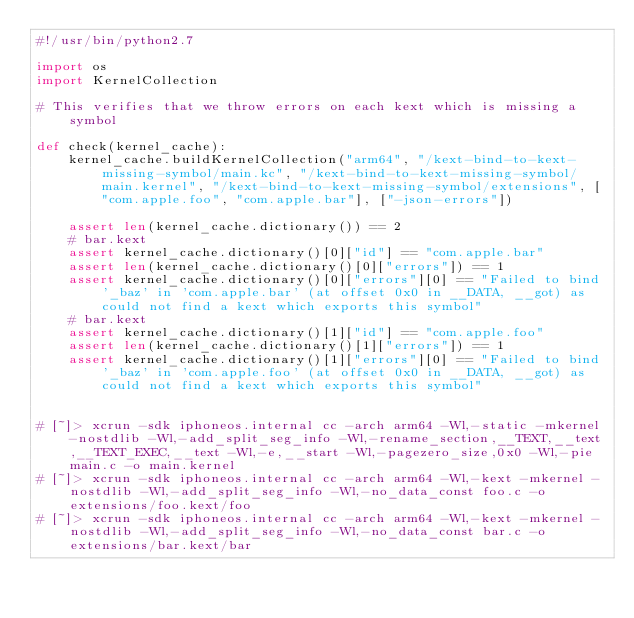Convert code to text. <code><loc_0><loc_0><loc_500><loc_500><_Python_>#!/usr/bin/python2.7

import os
import KernelCollection

# This verifies that we throw errors on each kext which is missing a symbol

def check(kernel_cache):
    kernel_cache.buildKernelCollection("arm64", "/kext-bind-to-kext-missing-symbol/main.kc", "/kext-bind-to-kext-missing-symbol/main.kernel", "/kext-bind-to-kext-missing-symbol/extensions", ["com.apple.foo", "com.apple.bar"], ["-json-errors"])

    assert len(kernel_cache.dictionary()) == 2
    # bar.kext
    assert kernel_cache.dictionary()[0]["id"] == "com.apple.bar"
    assert len(kernel_cache.dictionary()[0]["errors"]) == 1
    assert kernel_cache.dictionary()[0]["errors"][0] == "Failed to bind '_baz' in 'com.apple.bar' (at offset 0x0 in __DATA, __got) as could not find a kext which exports this symbol"
    # bar.kext
    assert kernel_cache.dictionary()[1]["id"] == "com.apple.foo"
    assert len(kernel_cache.dictionary()[1]["errors"]) == 1
    assert kernel_cache.dictionary()[1]["errors"][0] == "Failed to bind '_baz' in 'com.apple.foo' (at offset 0x0 in __DATA, __got) as could not find a kext which exports this symbol"


# [~]> xcrun -sdk iphoneos.internal cc -arch arm64 -Wl,-static -mkernel -nostdlib -Wl,-add_split_seg_info -Wl,-rename_section,__TEXT,__text,__TEXT_EXEC,__text -Wl,-e,__start -Wl,-pagezero_size,0x0 -Wl,-pie main.c -o main.kernel
# [~]> xcrun -sdk iphoneos.internal cc -arch arm64 -Wl,-kext -mkernel -nostdlib -Wl,-add_split_seg_info -Wl,-no_data_const foo.c -o extensions/foo.kext/foo
# [~]> xcrun -sdk iphoneos.internal cc -arch arm64 -Wl,-kext -mkernel -nostdlib -Wl,-add_split_seg_info -Wl,-no_data_const bar.c -o extensions/bar.kext/bar</code> 